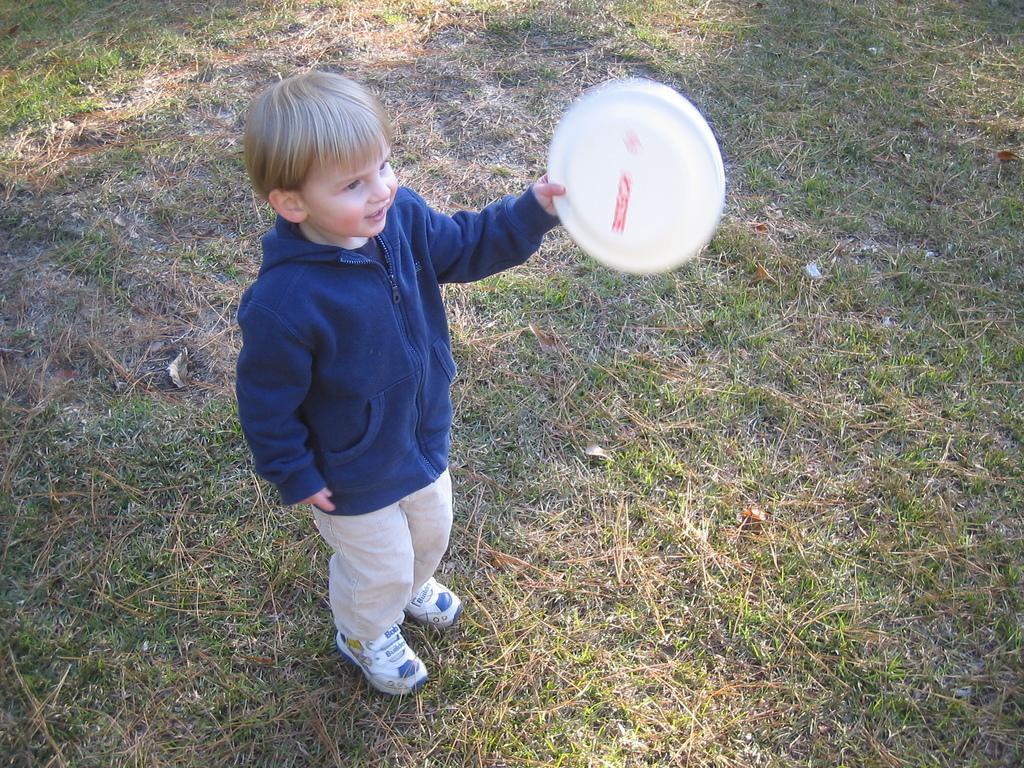Describe this image in one or two sentences. This image consists of a boy wearing a blue jacket. He is holding a frisbee. At the bottom, there is green grass on the ground. The boy is wearing white shoes. 